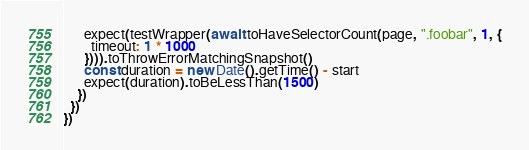Convert code to text. <code><loc_0><loc_0><loc_500><loc_500><_TypeScript_>      expect(testWrapper(await toHaveSelectorCount(page, ".foobar", 1, {
        timeout: 1 * 1000
      }))).toThrowErrorMatchingSnapshot()
      const duration = new Date().getTime() - start
      expect(duration).toBeLessThan(1500)
    })
  })
})
</code> 